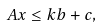Convert formula to latex. <formula><loc_0><loc_0><loc_500><loc_500>A x \leq k b + c ,</formula> 